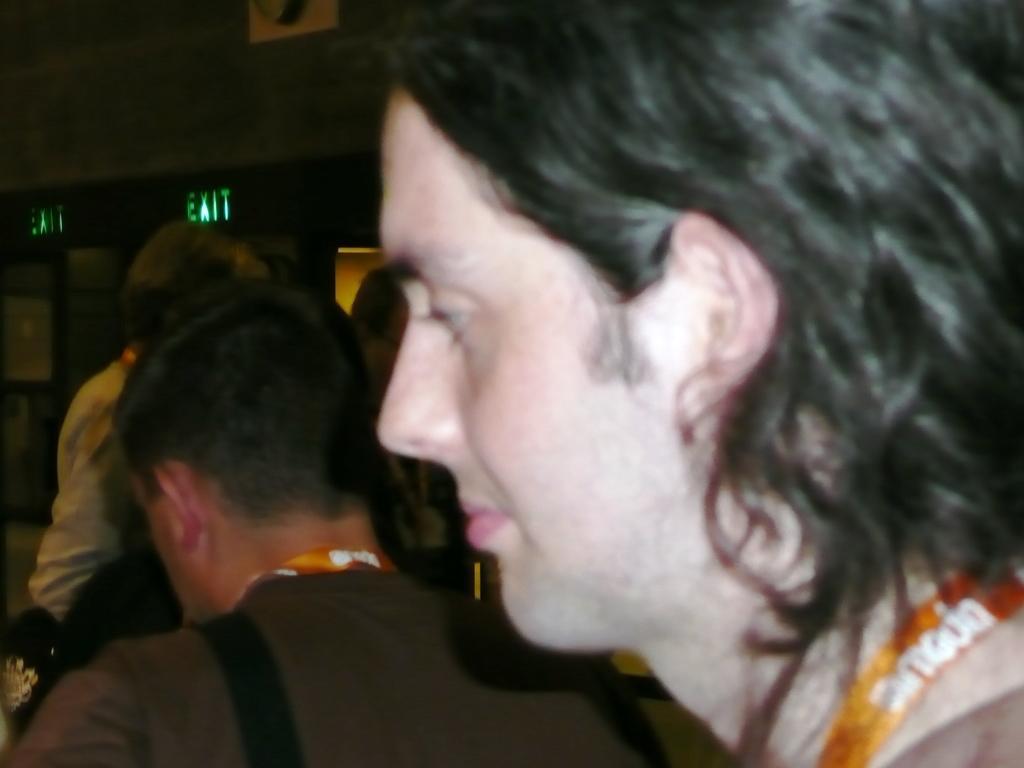Describe this image in one or two sentences. In this picture I can see there are few people standing here and the man on to right is wearing a tag and a shirt, he is looking at left side and there is a wall in the backdrop. 